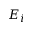Convert formula to latex. <formula><loc_0><loc_0><loc_500><loc_500>E _ { i }</formula> 